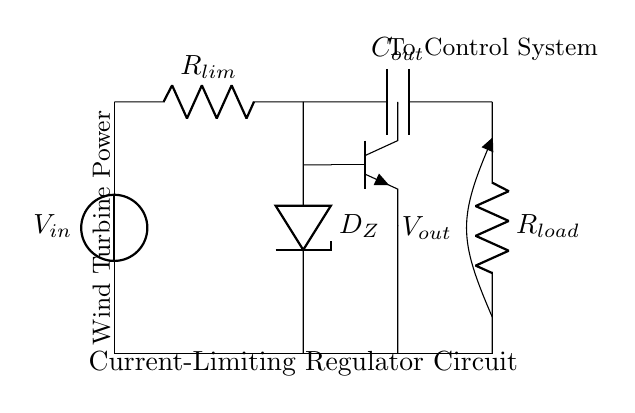What is the function of the Zener diode in this circuit? The Zener diode is used to regulate the voltage across the output, maintaining it at a specified level regardless of variations in input voltage or load conditions.
Answer: Voltage regulation What is the role of the current-limiting resistor? The current-limiting resistor is designed to restrict the flow of current to prevent damage to sensitive components in the circuit.
Answer: Current restriction What type of transistor is used in the circuit? The circuit uses an NPN transistor, identifiable by its three terminals: emitter, base, and collector.
Answer: NPN What do the labels "V_in" and "V_out" represent in the circuit? "V_in" represents the input voltage supplied to the circuit, while "V_out" represents the output voltage provided to the load.
Answer: Input and output voltages How does the circuit protect sensitive components? The circuit uses the current-limiting resistor and the Zener diode to control voltage and current levels, reducing the risk of overcurrent and overvoltage that can harm sensitive components.
Answer: Through regulation and limitation What is the effect of increasing the load resistance "R_load"? Increasing the load resistance reduces the current drawn from the regulator, which may lead to a higher output voltage closer to the Zener voltage if the current remains within limits.
Answer: Higher output voltage Which component is responsible for buffering the output in this circuit? The output capacitor buffers the output voltage by smoothing out fluctuations and providing charge when there are changes in load current.
Answer: Output capacitor 